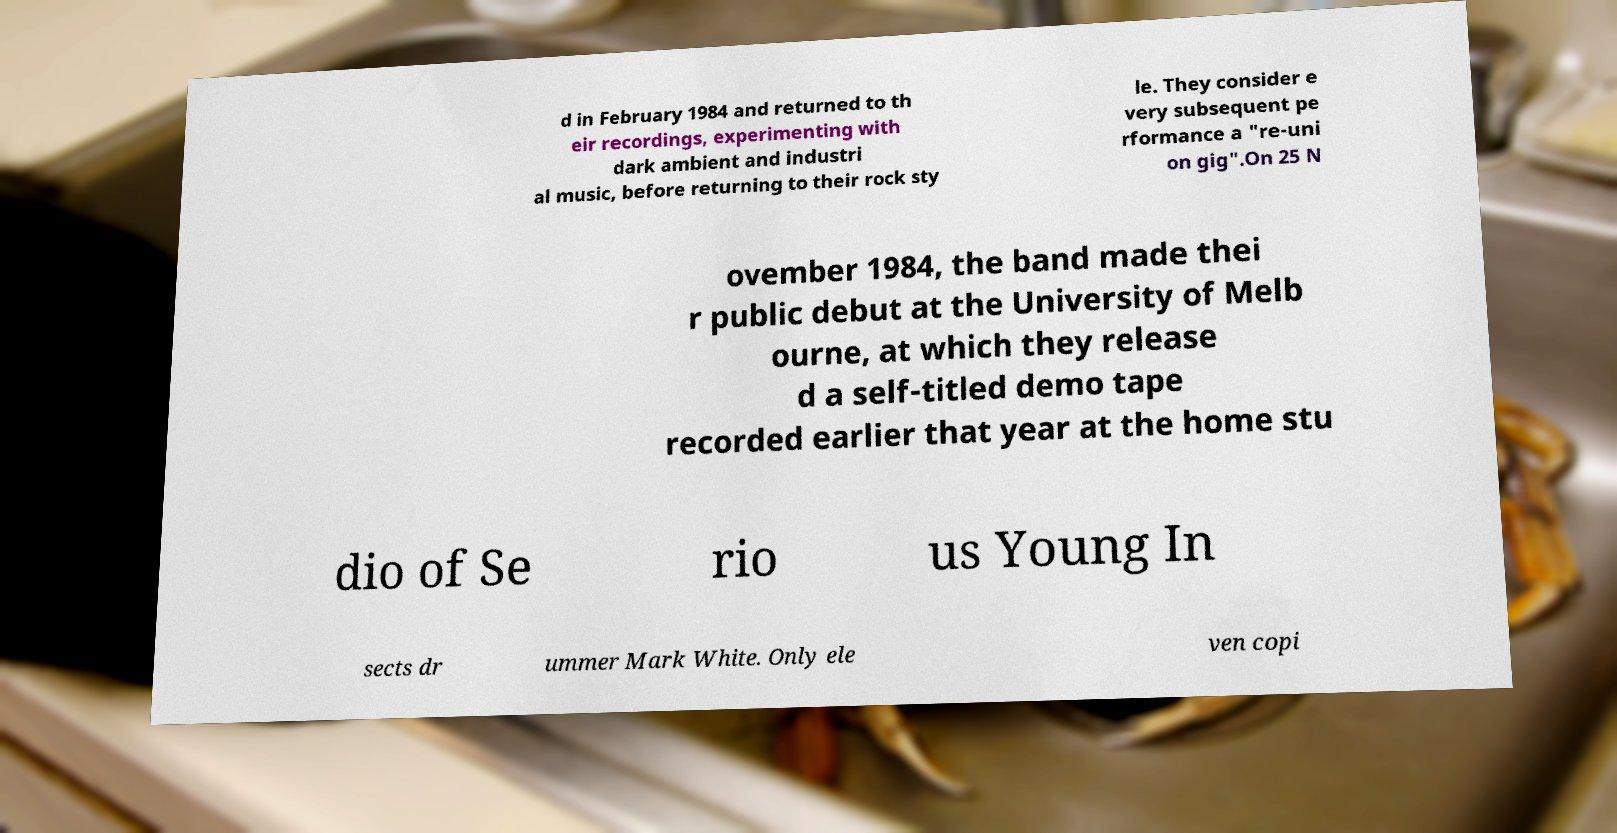Please read and relay the text visible in this image. What does it say? d in February 1984 and returned to th eir recordings, experimenting with dark ambient and industri al music, before returning to their rock sty le. They consider e very subsequent pe rformance a "re-uni on gig".On 25 N ovember 1984, the band made thei r public debut at the University of Melb ourne, at which they release d a self-titled demo tape recorded earlier that year at the home stu dio of Se rio us Young In sects dr ummer Mark White. Only ele ven copi 